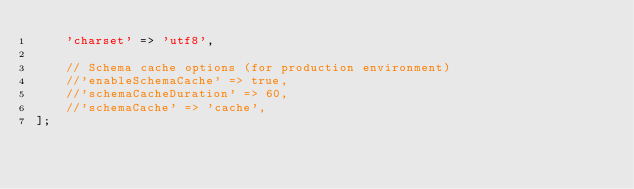Convert code to text. <code><loc_0><loc_0><loc_500><loc_500><_PHP_>    'charset' => 'utf8',

    // Schema cache options (for production environment)
    //'enableSchemaCache' => true,
    //'schemaCacheDuration' => 60,
    //'schemaCache' => 'cache',
];
</code> 